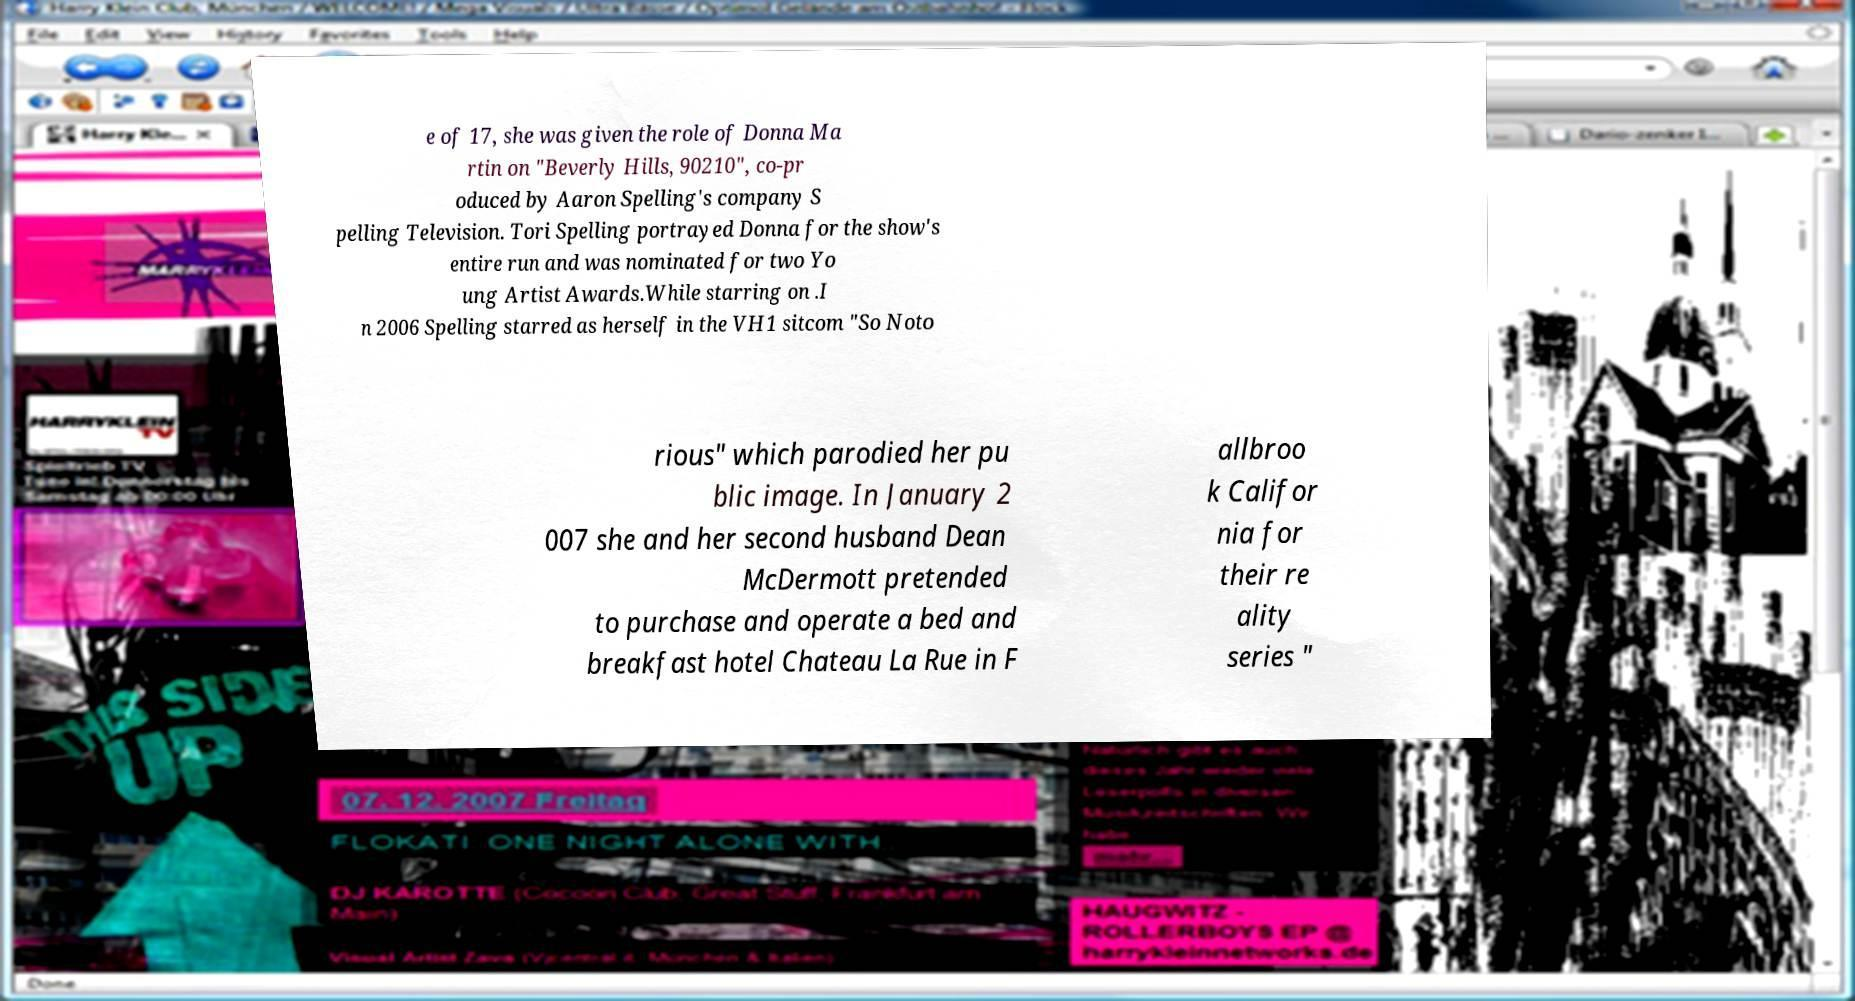Can you read and provide the text displayed in the image?This photo seems to have some interesting text. Can you extract and type it out for me? e of 17, she was given the role of Donna Ma rtin on "Beverly Hills, 90210", co-pr oduced by Aaron Spelling's company S pelling Television. Tori Spelling portrayed Donna for the show's entire run and was nominated for two Yo ung Artist Awards.While starring on .I n 2006 Spelling starred as herself in the VH1 sitcom "So Noto rious" which parodied her pu blic image. In January 2 007 she and her second husband Dean McDermott pretended to purchase and operate a bed and breakfast hotel Chateau La Rue in F allbroo k Califor nia for their re ality series " 